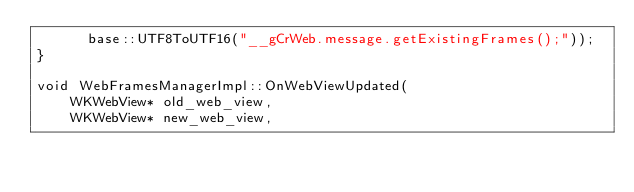<code> <loc_0><loc_0><loc_500><loc_500><_ObjectiveC_>      base::UTF8ToUTF16("__gCrWeb.message.getExistingFrames();"));
}

void WebFramesManagerImpl::OnWebViewUpdated(
    WKWebView* old_web_view,
    WKWebView* new_web_view,</code> 